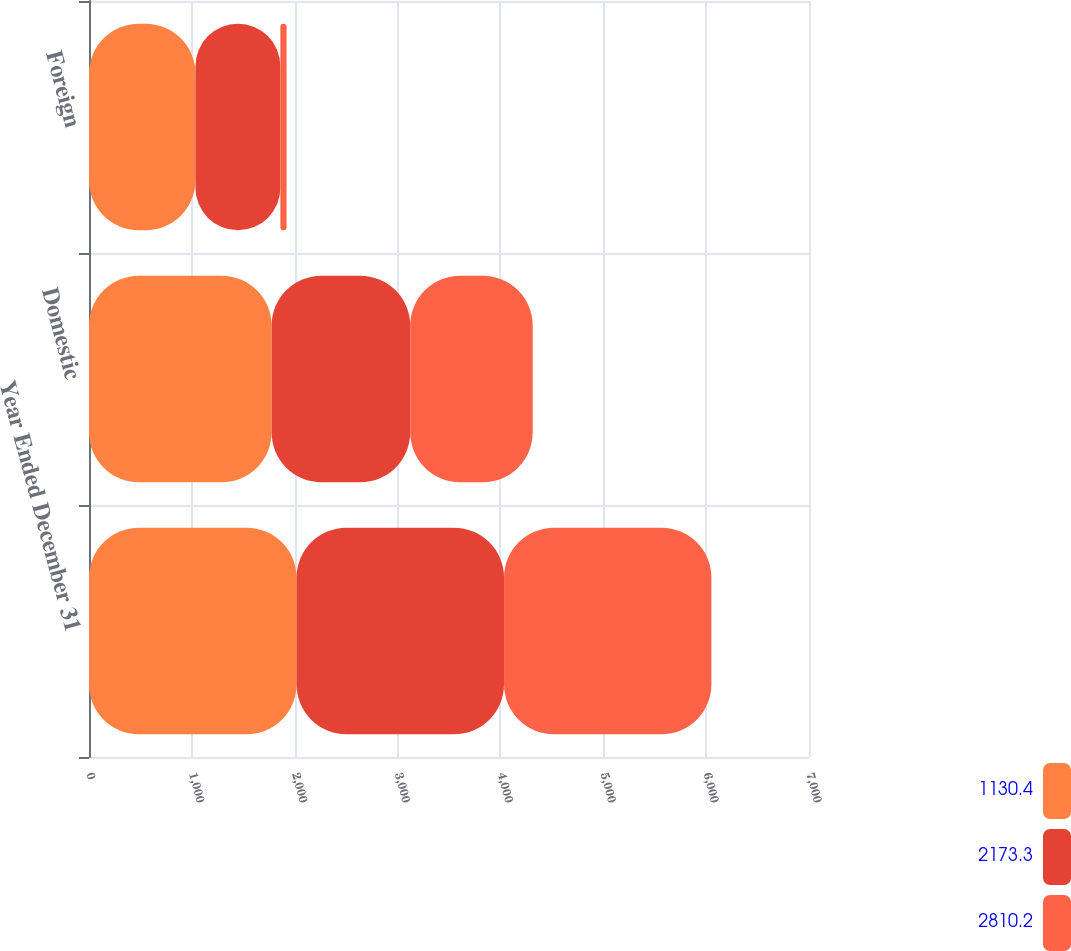Convert chart to OTSL. <chart><loc_0><loc_0><loc_500><loc_500><stacked_bar_chart><ecel><fcel>Year Ended December 31<fcel>Domestic<fcel>Foreign<nl><fcel>1130.4<fcel>2018<fcel>1775.2<fcel>1035<nl><fcel>2173.3<fcel>2017<fcel>1347.8<fcel>825.5<nl><fcel>2810.2<fcel>2016<fcel>1190.7<fcel>60.3<nl></chart> 